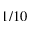<formula> <loc_0><loc_0><loc_500><loc_500>1 / 1 0</formula> 